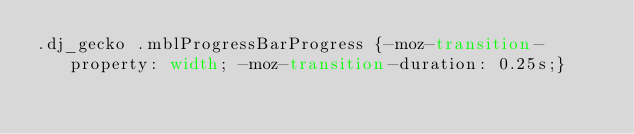<code> <loc_0><loc_0><loc_500><loc_500><_CSS_>.dj_gecko .mblProgressBarProgress {-moz-transition-property: width; -moz-transition-duration: 0.25s;}</code> 